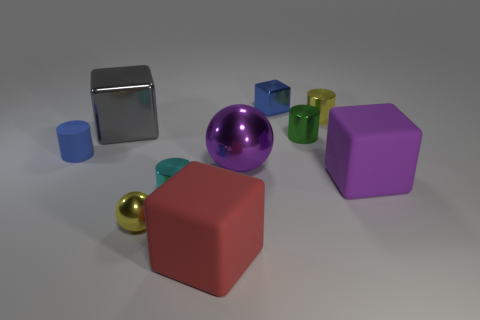What size is the block that is both right of the purple metal sphere and to the left of the big purple matte cube? small 